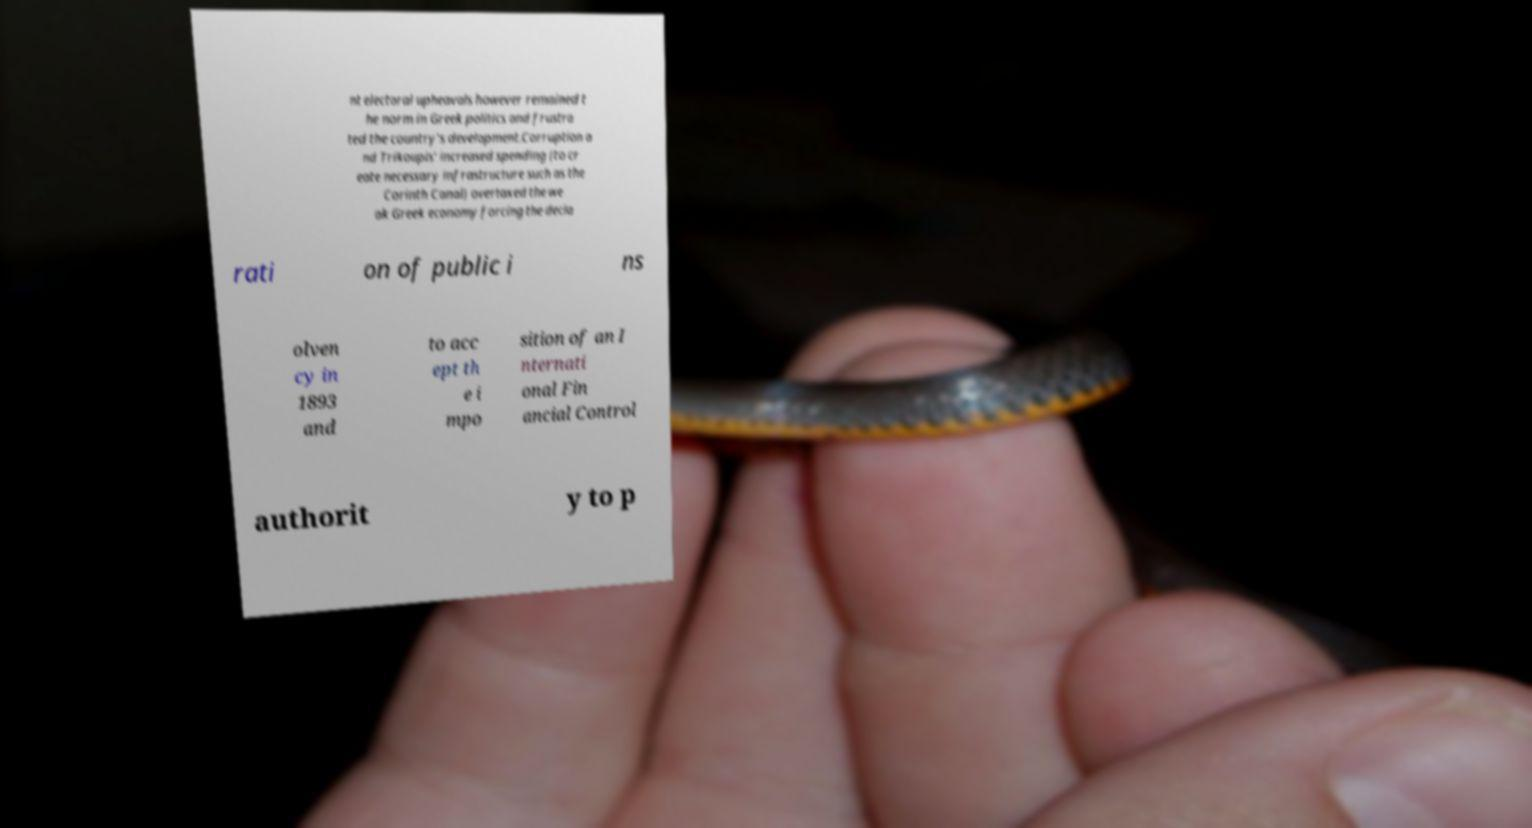Can you accurately transcribe the text from the provided image for me? nt electoral upheavals however remained t he norm in Greek politics and frustra ted the country's development.Corruption a nd Trikoupis' increased spending (to cr eate necessary infrastructure such as the Corinth Canal) overtaxed the we ak Greek economy forcing the decla rati on of public i ns olven cy in 1893 and to acc ept th e i mpo sition of an I nternati onal Fin ancial Control authorit y to p 